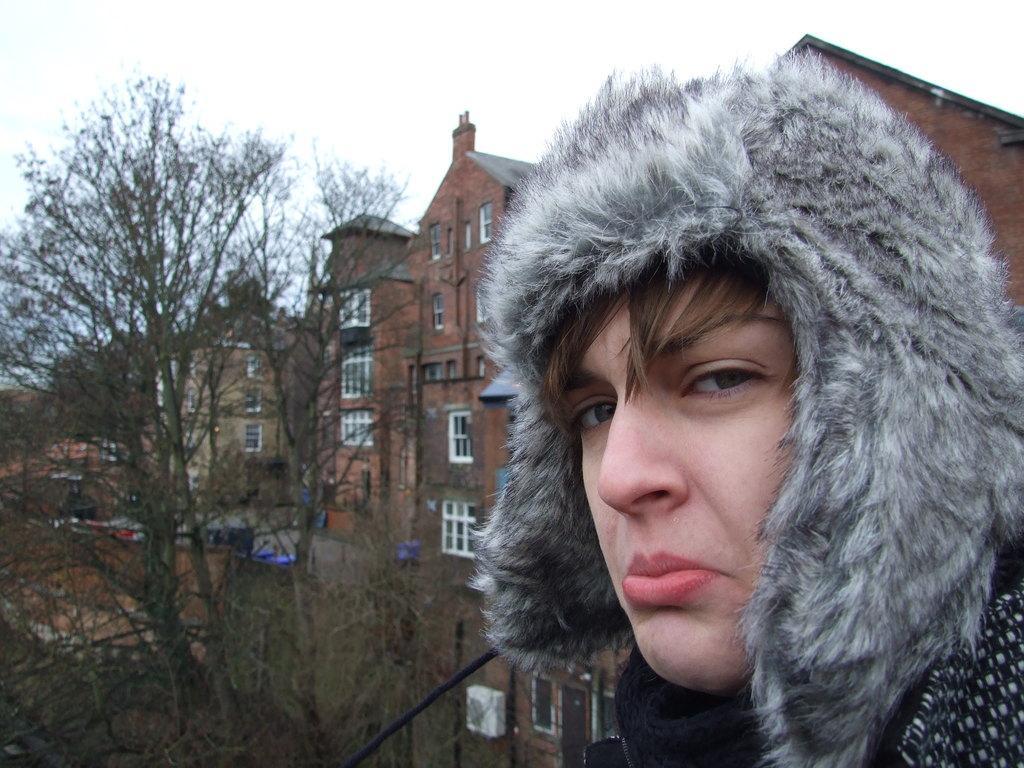In one or two sentences, can you explain what this image depicts? In this image, we can see a person wearing a coat and in the background, there are trees and buildings. At the top, there is sky. 